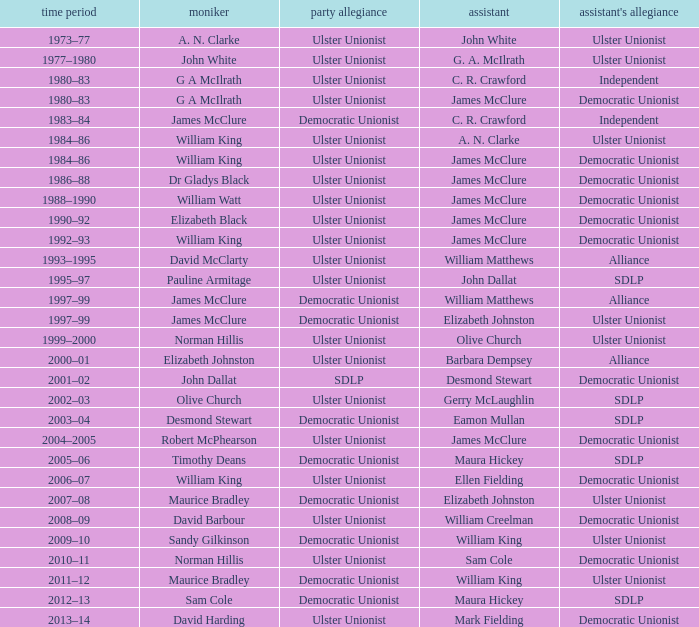What is the Political affiliation of deputy john dallat? Ulster Unionist. 